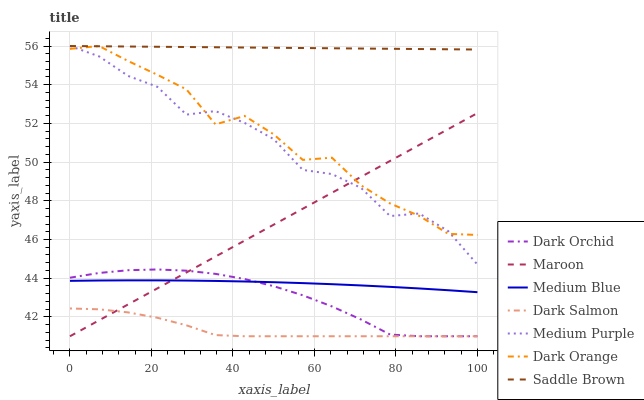Does Dark Salmon have the minimum area under the curve?
Answer yes or no. Yes. Does Saddle Brown have the maximum area under the curve?
Answer yes or no. Yes. Does Medium Blue have the minimum area under the curve?
Answer yes or no. No. Does Medium Blue have the maximum area under the curve?
Answer yes or no. No. Is Maroon the smoothest?
Answer yes or no. Yes. Is Medium Purple the roughest?
Answer yes or no. Yes. Is Medium Blue the smoothest?
Answer yes or no. No. Is Medium Blue the roughest?
Answer yes or no. No. Does Dark Salmon have the lowest value?
Answer yes or no. Yes. Does Medium Blue have the lowest value?
Answer yes or no. No. Does Saddle Brown have the highest value?
Answer yes or no. Yes. Does Medium Blue have the highest value?
Answer yes or no. No. Is Medium Blue less than Dark Orange?
Answer yes or no. Yes. Is Medium Purple greater than Dark Orchid?
Answer yes or no. Yes. Does Maroon intersect Dark Orchid?
Answer yes or no. Yes. Is Maroon less than Dark Orchid?
Answer yes or no. No. Is Maroon greater than Dark Orchid?
Answer yes or no. No. Does Medium Blue intersect Dark Orange?
Answer yes or no. No. 